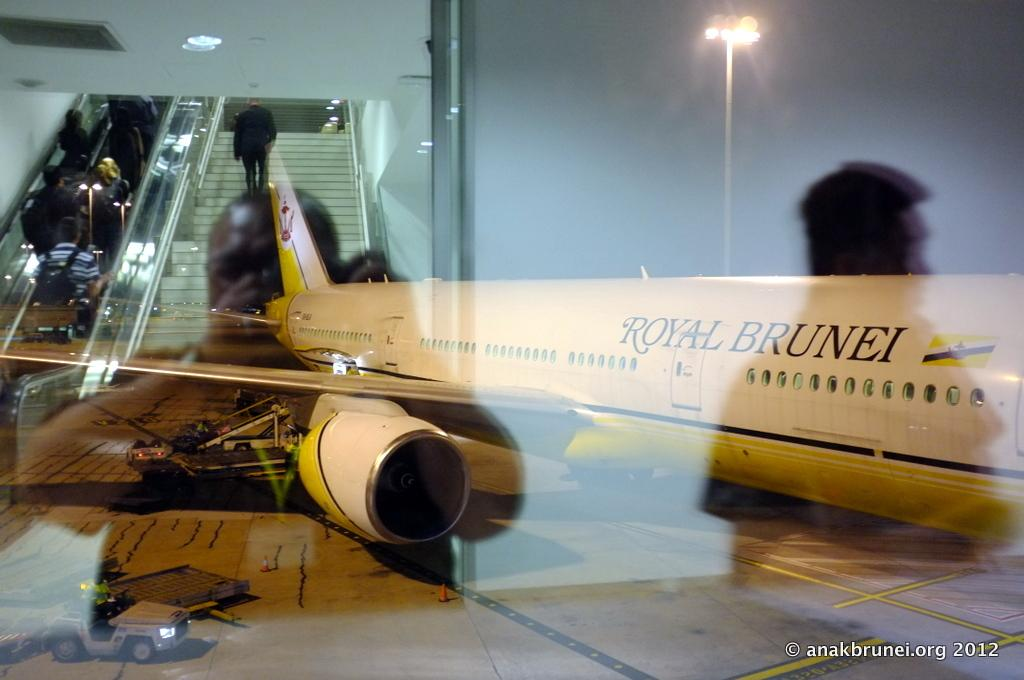<image>
Describe the image concisely. A Royal Brunei airplane sits on the runway at night. 